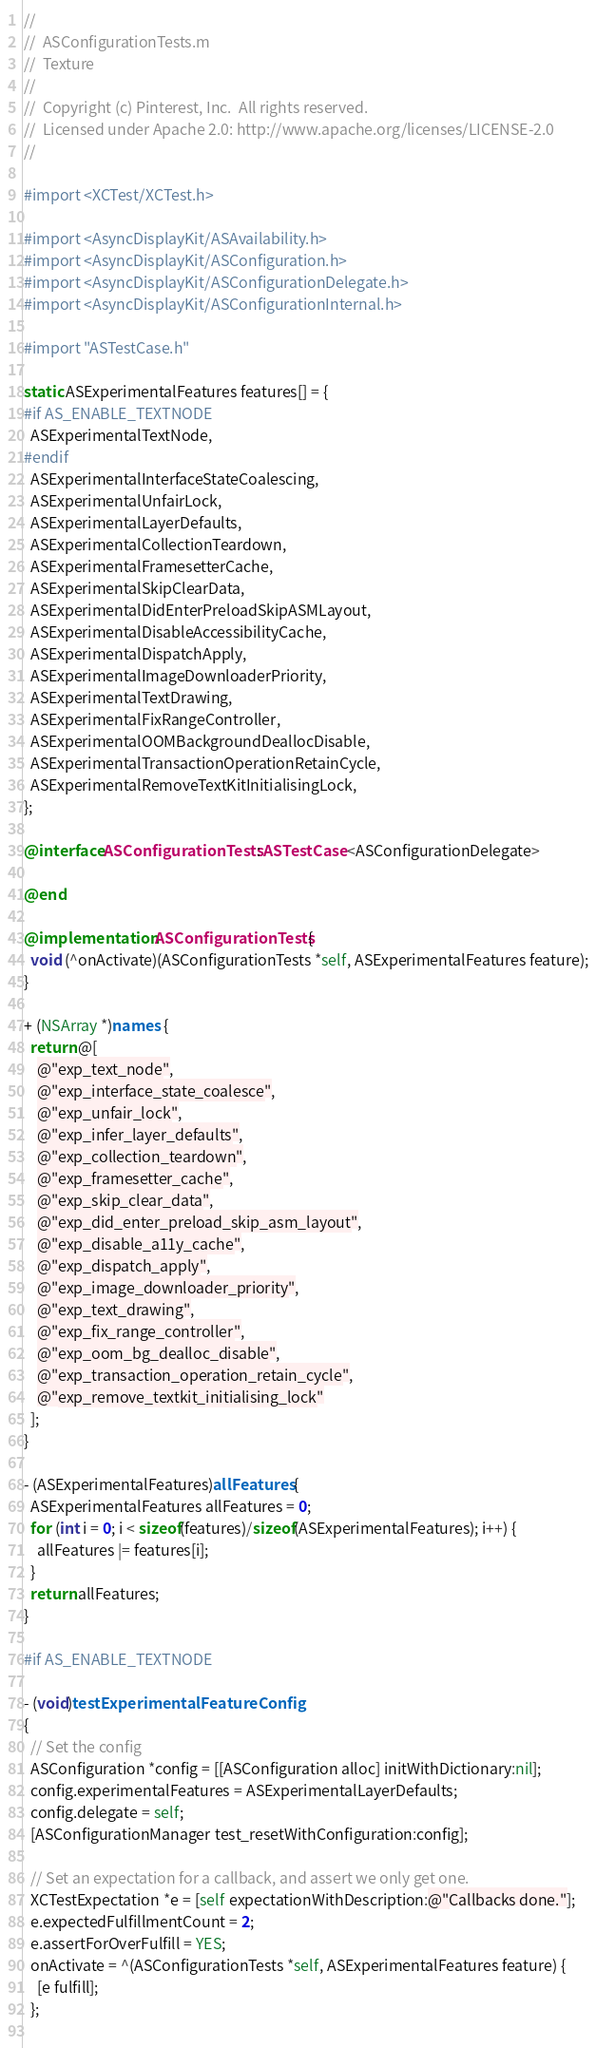<code> <loc_0><loc_0><loc_500><loc_500><_ObjectiveC_>//
//  ASConfigurationTests.m
//  Texture
//
//  Copyright (c) Pinterest, Inc.  All rights reserved.
//  Licensed under Apache 2.0: http://www.apache.org/licenses/LICENSE-2.0
//

#import <XCTest/XCTest.h>

#import <AsyncDisplayKit/ASAvailability.h>
#import <AsyncDisplayKit/ASConfiguration.h>
#import <AsyncDisplayKit/ASConfigurationDelegate.h>
#import <AsyncDisplayKit/ASConfigurationInternal.h>

#import "ASTestCase.h"

static ASExperimentalFeatures features[] = {
#if AS_ENABLE_TEXTNODE
  ASExperimentalTextNode,
#endif
  ASExperimentalInterfaceStateCoalescing,
  ASExperimentalUnfairLock,
  ASExperimentalLayerDefaults,
  ASExperimentalCollectionTeardown,
  ASExperimentalFramesetterCache,
  ASExperimentalSkipClearData,
  ASExperimentalDidEnterPreloadSkipASMLayout,
  ASExperimentalDisableAccessibilityCache,
  ASExperimentalDispatchApply,
  ASExperimentalImageDownloaderPriority,
  ASExperimentalTextDrawing,
  ASExperimentalFixRangeController,
  ASExperimentalOOMBackgroundDeallocDisable,
  ASExperimentalTransactionOperationRetainCycle,
  ASExperimentalRemoveTextKitInitialisingLock,
};

@interface ASConfigurationTests : ASTestCase <ASConfigurationDelegate>

@end

@implementation ASConfigurationTests {
  void (^onActivate)(ASConfigurationTests *self, ASExperimentalFeatures feature);
}

+ (NSArray *)names {
  return @[
    @"exp_text_node",
    @"exp_interface_state_coalesce",
    @"exp_unfair_lock",
    @"exp_infer_layer_defaults",
    @"exp_collection_teardown",
    @"exp_framesetter_cache",
    @"exp_skip_clear_data",
    @"exp_did_enter_preload_skip_asm_layout",
    @"exp_disable_a11y_cache",
    @"exp_dispatch_apply",
    @"exp_image_downloader_priority",
    @"exp_text_drawing",
    @"exp_fix_range_controller",
    @"exp_oom_bg_dealloc_disable",
    @"exp_transaction_operation_retain_cycle",
    @"exp_remove_textkit_initialising_lock"
  ];
}

- (ASExperimentalFeatures)allFeatures {
  ASExperimentalFeatures allFeatures = 0;
  for (int i = 0; i < sizeof(features)/sizeof(ASExperimentalFeatures); i++) {
    allFeatures |= features[i];
  }
  return allFeatures;
}

#if AS_ENABLE_TEXTNODE

- (void)testExperimentalFeatureConfig
{
  // Set the config
  ASConfiguration *config = [[ASConfiguration alloc] initWithDictionary:nil];
  config.experimentalFeatures = ASExperimentalLayerDefaults;
  config.delegate = self;
  [ASConfigurationManager test_resetWithConfiguration:config];
  
  // Set an expectation for a callback, and assert we only get one.
  XCTestExpectation *e = [self expectationWithDescription:@"Callbacks done."];
  e.expectedFulfillmentCount = 2;
  e.assertForOverFulfill = YES;
  onActivate = ^(ASConfigurationTests *self, ASExperimentalFeatures feature) {
    [e fulfill];
  };
  </code> 